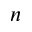<formula> <loc_0><loc_0><loc_500><loc_500>n</formula> 